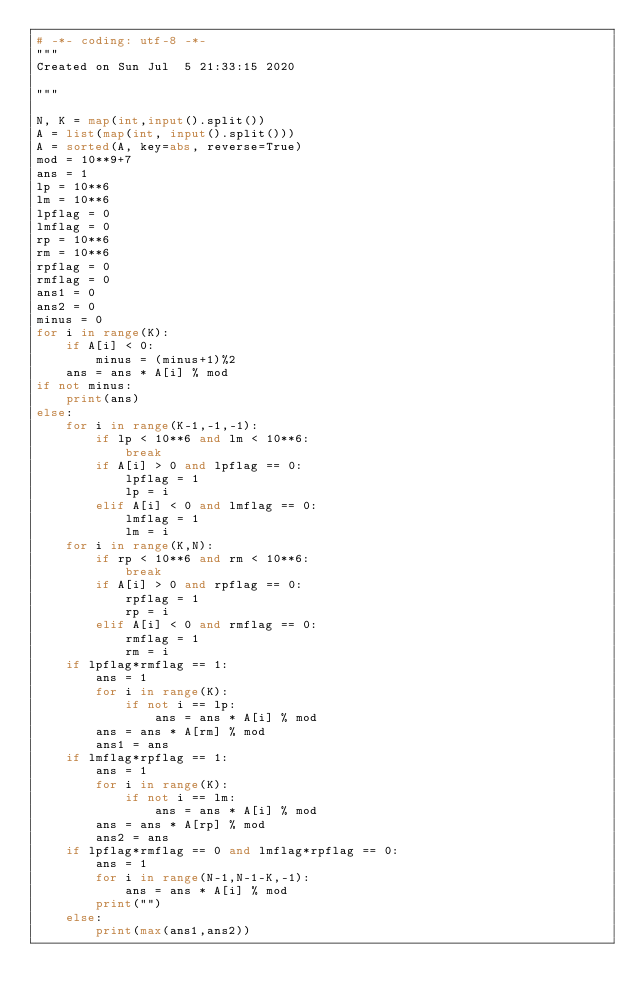Convert code to text. <code><loc_0><loc_0><loc_500><loc_500><_Python_># -*- coding: utf-8 -*-
"""
Created on Sun Jul  5 21:33:15 2020

"""

N, K = map(int,input().split())
A = list(map(int, input().split())) 
A = sorted(A, key=abs, reverse=True)
mod = 10**9+7
ans = 1
lp = 10**6
lm = 10**6
lpflag = 0
lmflag = 0
rp = 10**6
rm = 10**6
rpflag = 0
rmflag = 0
ans1 = 0
ans2 = 0
minus = 0
for i in range(K):
    if A[i] < 0:
        minus = (minus+1)%2
    ans = ans * A[i] % mod
if not minus:
    print(ans)
else:
    for i in range(K-1,-1,-1):
        if lp < 10**6 and lm < 10**6:
            break
        if A[i] > 0 and lpflag == 0:
            lpflag = 1
            lp = i
        elif A[i] < 0 and lmflag == 0:
            lmflag = 1
            lm = i
    for i in range(K,N):
        if rp < 10**6 and rm < 10**6:
            break
        if A[i] > 0 and rpflag == 0:
            rpflag = 1
            rp = i
        elif A[i] < 0 and rmflag == 0:
            rmflag = 1
            rm = i
    if lpflag*rmflag == 1:
        ans = 1
        for i in range(K):
            if not i == lp:
                ans = ans * A[i] % mod
        ans = ans * A[rm] % mod
        ans1 = ans
    if lmflag*rpflag == 1:
        ans = 1
        for i in range(K):
            if not i == lm:
                ans = ans * A[i] % mod
        ans = ans * A[rp] % mod    
        ans2 = ans
    if lpflag*rmflag == 0 and lmflag*rpflag == 0:
        ans = 1
        for i in range(N-1,N-1-K,-1):
            ans = ans * A[i] % mod
        print("")
    else:
        print(max(ans1,ans2))
        
        
   
</code> 